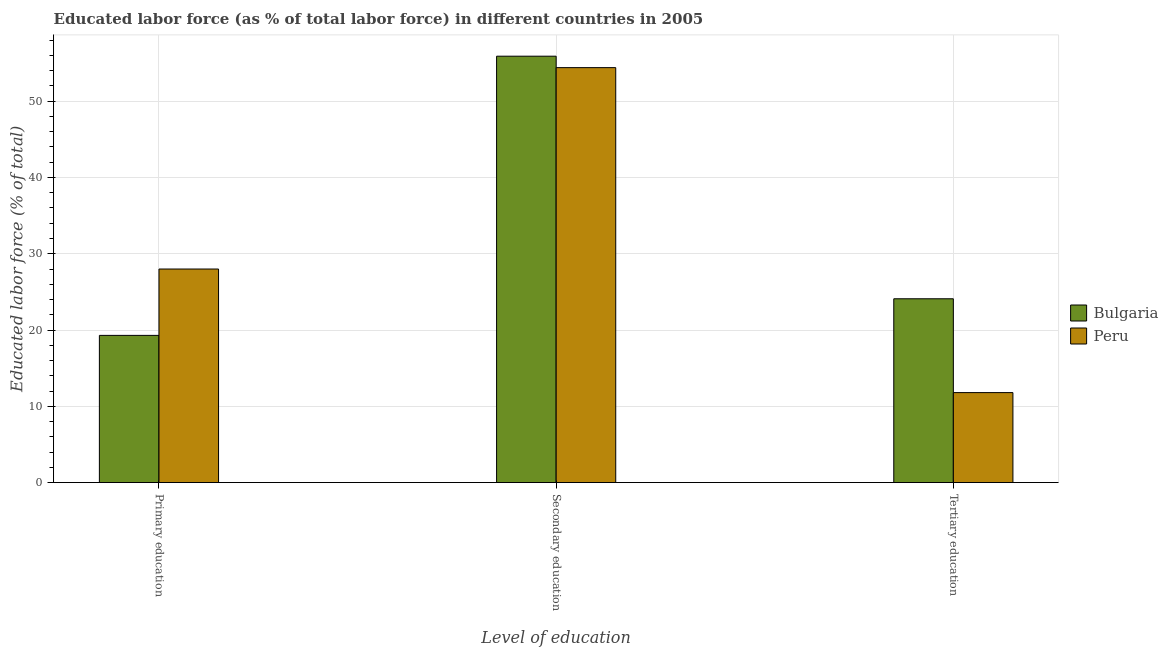How many different coloured bars are there?
Your answer should be very brief. 2. How many groups of bars are there?
Your answer should be compact. 3. Are the number of bars per tick equal to the number of legend labels?
Provide a succinct answer. Yes. Are the number of bars on each tick of the X-axis equal?
Your response must be concise. Yes. What is the percentage of labor force who received tertiary education in Bulgaria?
Your answer should be compact. 24.1. Across all countries, what is the maximum percentage of labor force who received tertiary education?
Keep it short and to the point. 24.1. Across all countries, what is the minimum percentage of labor force who received tertiary education?
Give a very brief answer. 11.8. In which country was the percentage of labor force who received primary education maximum?
Your response must be concise. Peru. What is the total percentage of labor force who received secondary education in the graph?
Ensure brevity in your answer.  110.3. What is the difference between the percentage of labor force who received secondary education in Bulgaria and the percentage of labor force who received tertiary education in Peru?
Provide a short and direct response. 44.1. What is the average percentage of labor force who received secondary education per country?
Your answer should be very brief. 55.15. What is the difference between the percentage of labor force who received secondary education and percentage of labor force who received tertiary education in Bulgaria?
Your response must be concise. 31.8. In how many countries, is the percentage of labor force who received primary education greater than 12 %?
Your answer should be very brief. 2. What is the ratio of the percentage of labor force who received tertiary education in Bulgaria to that in Peru?
Provide a short and direct response. 2.04. Is the percentage of labor force who received secondary education in Bulgaria less than that in Peru?
Give a very brief answer. No. What is the difference between the highest and the second highest percentage of labor force who received secondary education?
Make the answer very short. 1.5. What is the difference between the highest and the lowest percentage of labor force who received primary education?
Offer a terse response. 8.7. In how many countries, is the percentage of labor force who received secondary education greater than the average percentage of labor force who received secondary education taken over all countries?
Give a very brief answer. 1. Are all the bars in the graph horizontal?
Make the answer very short. No. What is the difference between two consecutive major ticks on the Y-axis?
Offer a terse response. 10. Where does the legend appear in the graph?
Provide a succinct answer. Center right. How many legend labels are there?
Your answer should be compact. 2. What is the title of the graph?
Offer a terse response. Educated labor force (as % of total labor force) in different countries in 2005. Does "Nepal" appear as one of the legend labels in the graph?
Ensure brevity in your answer.  No. What is the label or title of the X-axis?
Keep it short and to the point. Level of education. What is the label or title of the Y-axis?
Offer a very short reply. Educated labor force (% of total). What is the Educated labor force (% of total) in Bulgaria in Primary education?
Provide a succinct answer. 19.3. What is the Educated labor force (% of total) of Bulgaria in Secondary education?
Keep it short and to the point. 55.9. What is the Educated labor force (% of total) of Peru in Secondary education?
Provide a short and direct response. 54.4. What is the Educated labor force (% of total) of Bulgaria in Tertiary education?
Your answer should be very brief. 24.1. What is the Educated labor force (% of total) in Peru in Tertiary education?
Offer a terse response. 11.8. Across all Level of education, what is the maximum Educated labor force (% of total) of Bulgaria?
Offer a very short reply. 55.9. Across all Level of education, what is the maximum Educated labor force (% of total) of Peru?
Your answer should be very brief. 54.4. Across all Level of education, what is the minimum Educated labor force (% of total) in Bulgaria?
Provide a short and direct response. 19.3. Across all Level of education, what is the minimum Educated labor force (% of total) of Peru?
Provide a succinct answer. 11.8. What is the total Educated labor force (% of total) in Bulgaria in the graph?
Provide a succinct answer. 99.3. What is the total Educated labor force (% of total) of Peru in the graph?
Your response must be concise. 94.2. What is the difference between the Educated labor force (% of total) in Bulgaria in Primary education and that in Secondary education?
Give a very brief answer. -36.6. What is the difference between the Educated labor force (% of total) of Peru in Primary education and that in Secondary education?
Give a very brief answer. -26.4. What is the difference between the Educated labor force (% of total) of Peru in Primary education and that in Tertiary education?
Ensure brevity in your answer.  16.2. What is the difference between the Educated labor force (% of total) of Bulgaria in Secondary education and that in Tertiary education?
Give a very brief answer. 31.8. What is the difference between the Educated labor force (% of total) of Peru in Secondary education and that in Tertiary education?
Keep it short and to the point. 42.6. What is the difference between the Educated labor force (% of total) of Bulgaria in Primary education and the Educated labor force (% of total) of Peru in Secondary education?
Offer a terse response. -35.1. What is the difference between the Educated labor force (% of total) of Bulgaria in Primary education and the Educated labor force (% of total) of Peru in Tertiary education?
Offer a terse response. 7.5. What is the difference between the Educated labor force (% of total) of Bulgaria in Secondary education and the Educated labor force (% of total) of Peru in Tertiary education?
Provide a short and direct response. 44.1. What is the average Educated labor force (% of total) of Bulgaria per Level of education?
Make the answer very short. 33.1. What is the average Educated labor force (% of total) of Peru per Level of education?
Provide a short and direct response. 31.4. What is the difference between the Educated labor force (% of total) of Bulgaria and Educated labor force (% of total) of Peru in Secondary education?
Your answer should be compact. 1.5. What is the ratio of the Educated labor force (% of total) of Bulgaria in Primary education to that in Secondary education?
Make the answer very short. 0.35. What is the ratio of the Educated labor force (% of total) of Peru in Primary education to that in Secondary education?
Offer a terse response. 0.51. What is the ratio of the Educated labor force (% of total) of Bulgaria in Primary education to that in Tertiary education?
Make the answer very short. 0.8. What is the ratio of the Educated labor force (% of total) in Peru in Primary education to that in Tertiary education?
Your answer should be compact. 2.37. What is the ratio of the Educated labor force (% of total) of Bulgaria in Secondary education to that in Tertiary education?
Make the answer very short. 2.32. What is the ratio of the Educated labor force (% of total) of Peru in Secondary education to that in Tertiary education?
Give a very brief answer. 4.61. What is the difference between the highest and the second highest Educated labor force (% of total) in Bulgaria?
Keep it short and to the point. 31.8. What is the difference between the highest and the second highest Educated labor force (% of total) of Peru?
Make the answer very short. 26.4. What is the difference between the highest and the lowest Educated labor force (% of total) in Bulgaria?
Ensure brevity in your answer.  36.6. What is the difference between the highest and the lowest Educated labor force (% of total) of Peru?
Your answer should be compact. 42.6. 